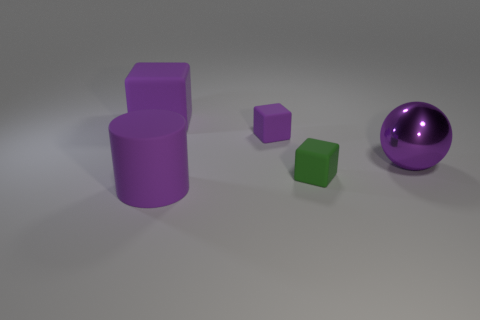What is the color of the small object that is left of the tiny matte thing in front of the small block behind the metal sphere?
Provide a succinct answer. Purple. There is a block that is the same size as the purple metal ball; what color is it?
Make the answer very short. Purple. The big purple rubber thing that is right of the large purple rubber object that is behind the large rubber object in front of the big shiny sphere is what shape?
Your answer should be very brief. Cylinder. There is a shiny object that is the same color as the cylinder; what shape is it?
Provide a succinct answer. Sphere. What number of things are either large cyan metallic cylinders or tiny objects that are behind the large purple ball?
Keep it short and to the point. 1. Do the purple object that is in front of the purple metallic object and the large cube have the same size?
Offer a terse response. Yes. What is the big purple thing in front of the large shiny ball made of?
Provide a short and direct response. Rubber. Are there an equal number of purple rubber cylinders that are behind the purple rubber cylinder and matte cubes to the right of the purple shiny thing?
Make the answer very short. Yes. What color is the other tiny rubber thing that is the same shape as the small purple object?
Offer a very short reply. Green. Are there any other things that have the same color as the big rubber cylinder?
Provide a short and direct response. Yes. 